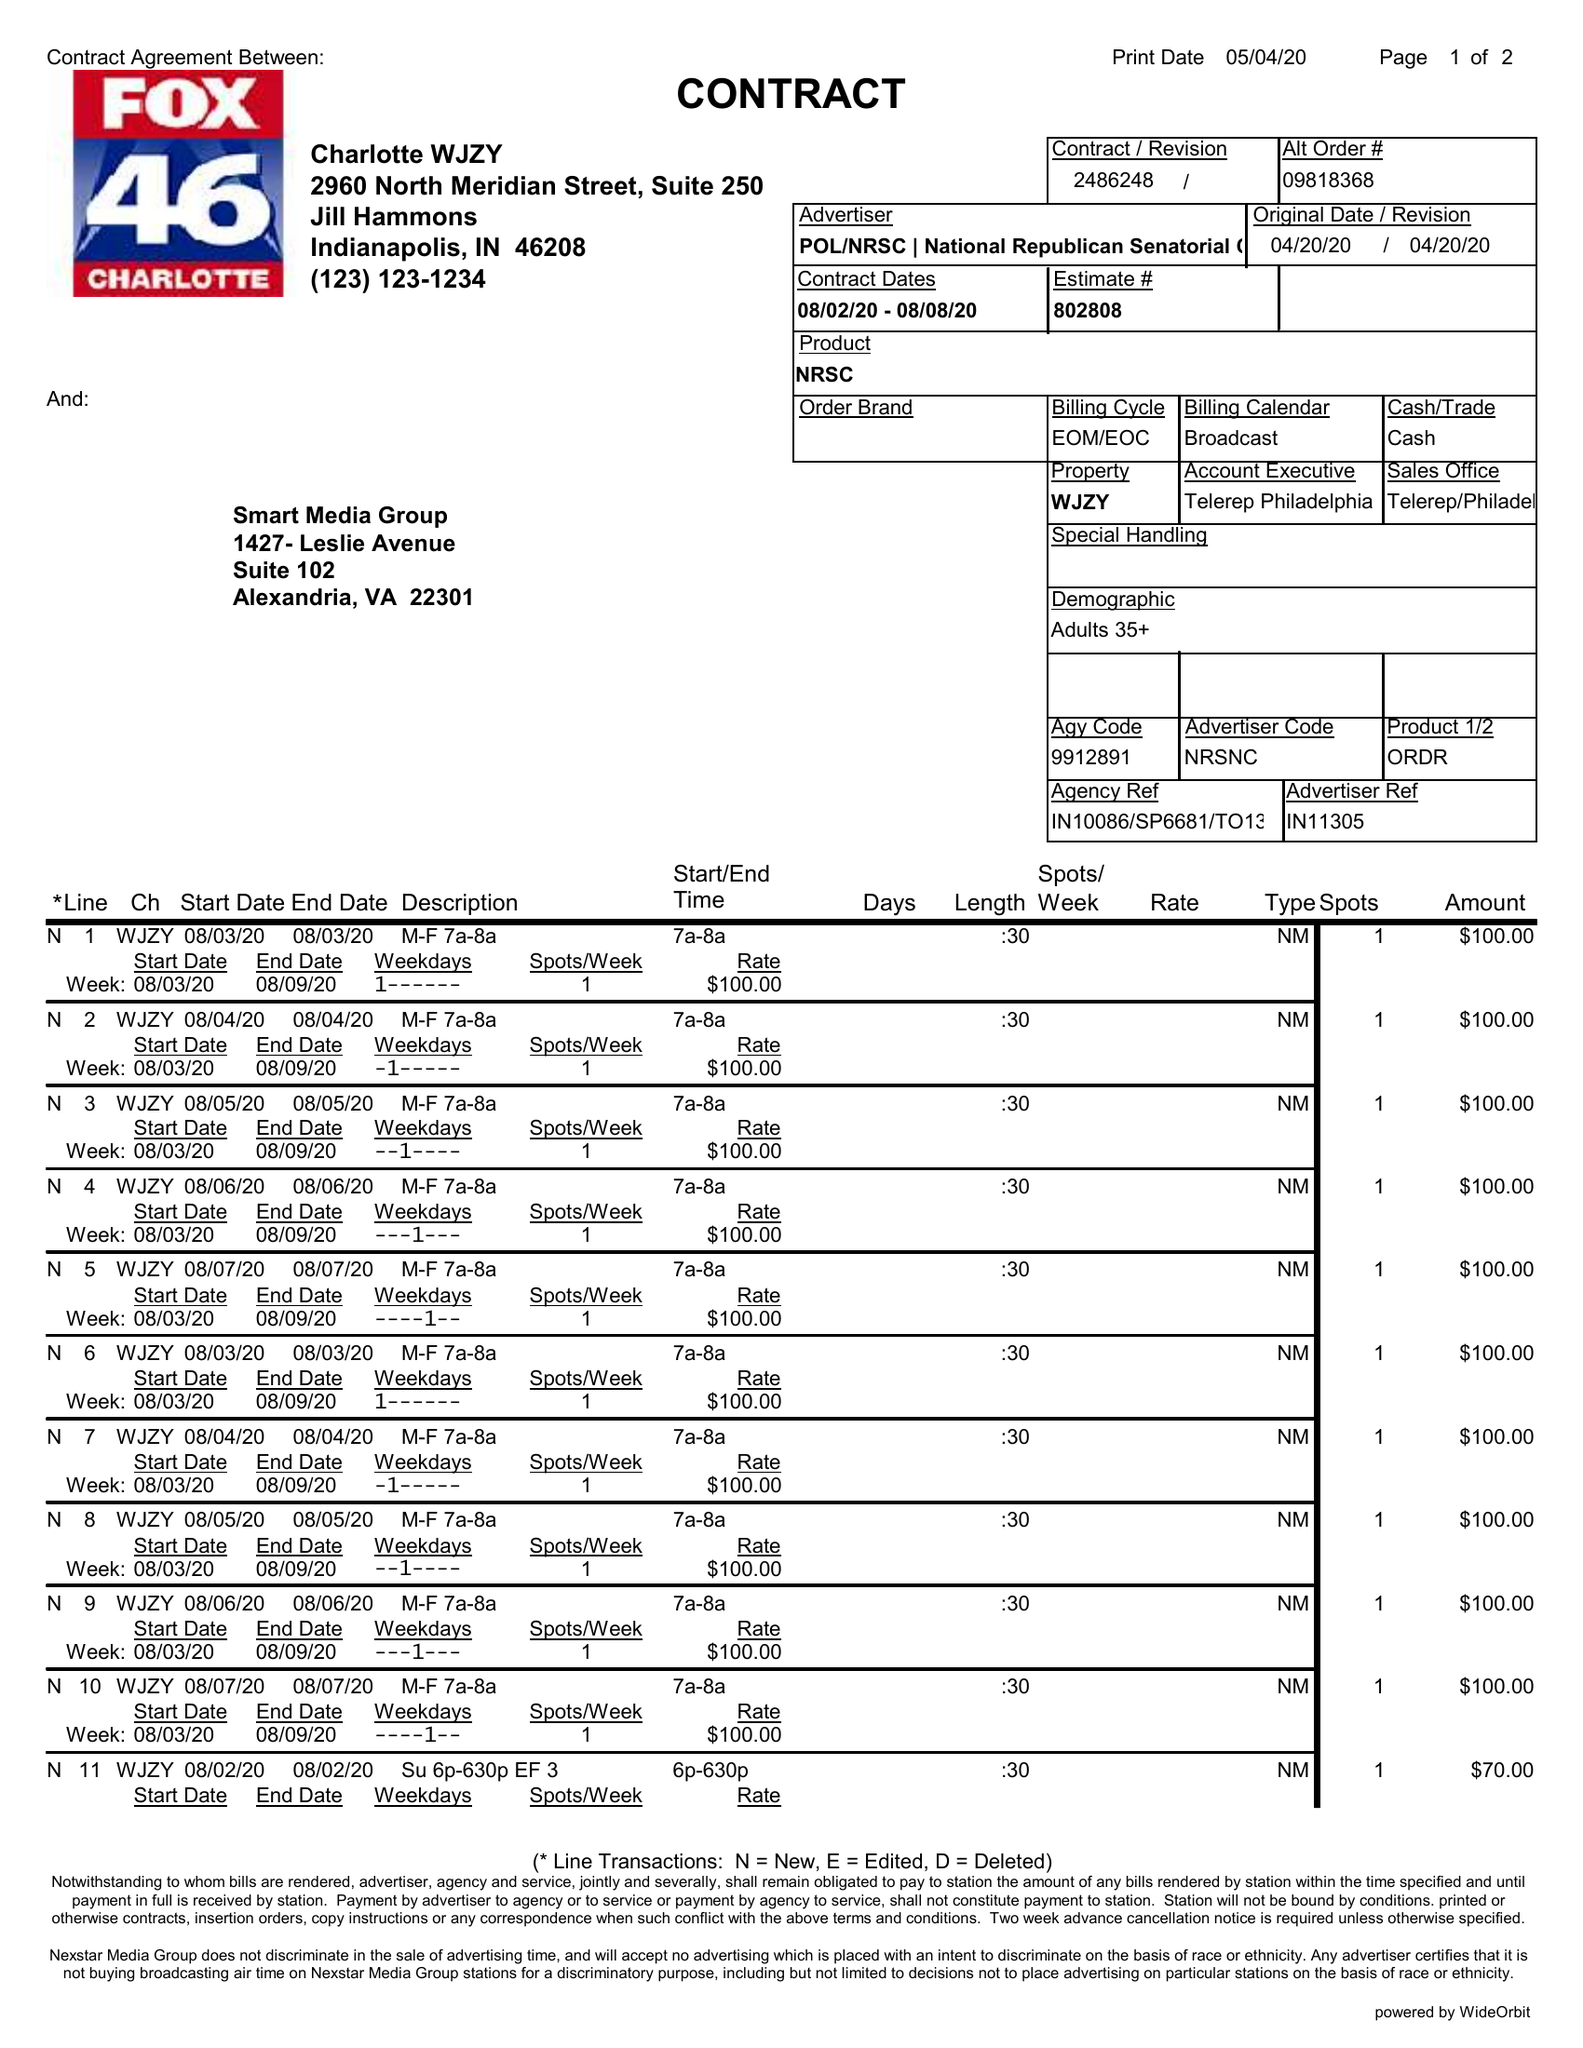What is the value for the gross_amount?
Answer the question using a single word or phrase. 1340.00 